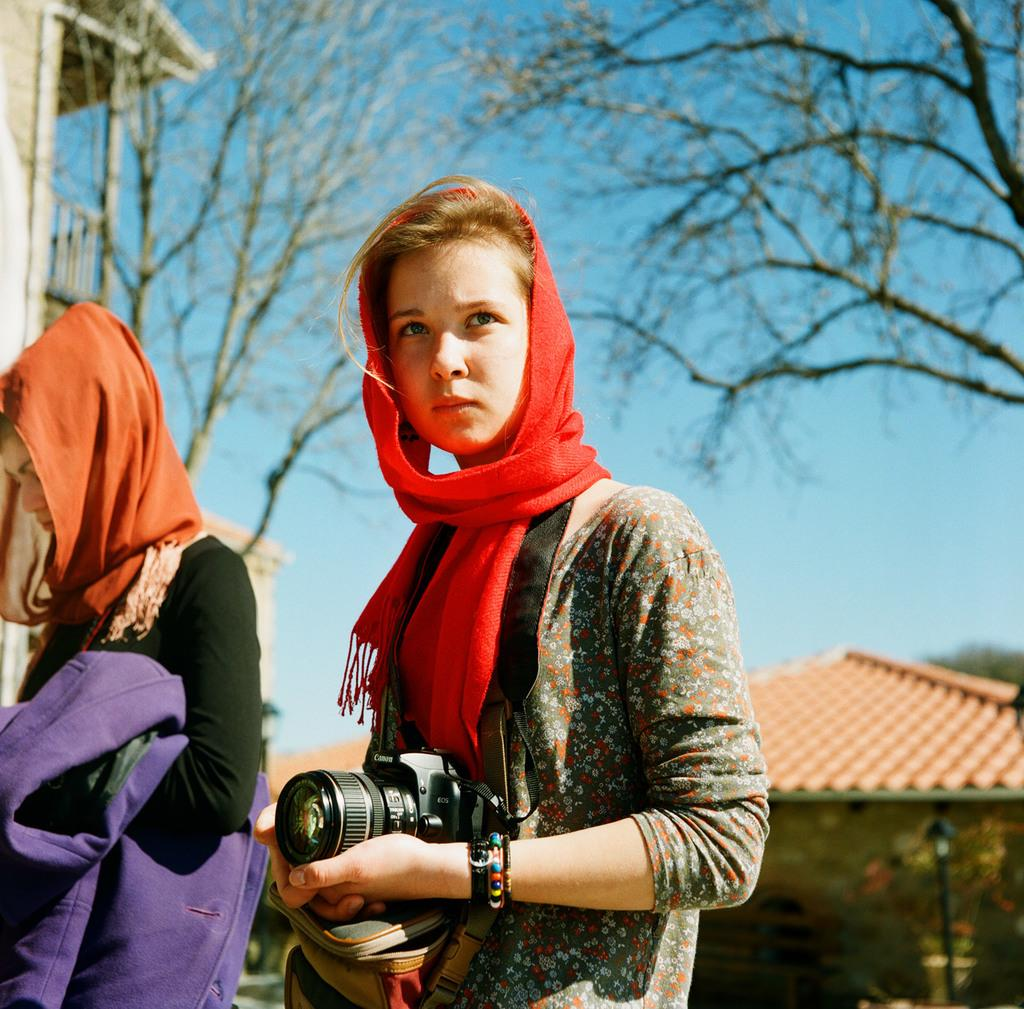What is the woman in the image doing? The woman is standing in the image and holding a camera in her hands. Is there anyone else in the image? Yes, there is another woman standing beside the first woman. What can be seen in the background of the image? There is a tree and the sky visible in the image. Can you tell me how many babies are playing with a kite in the image? There are no babies or kites present in the image. 